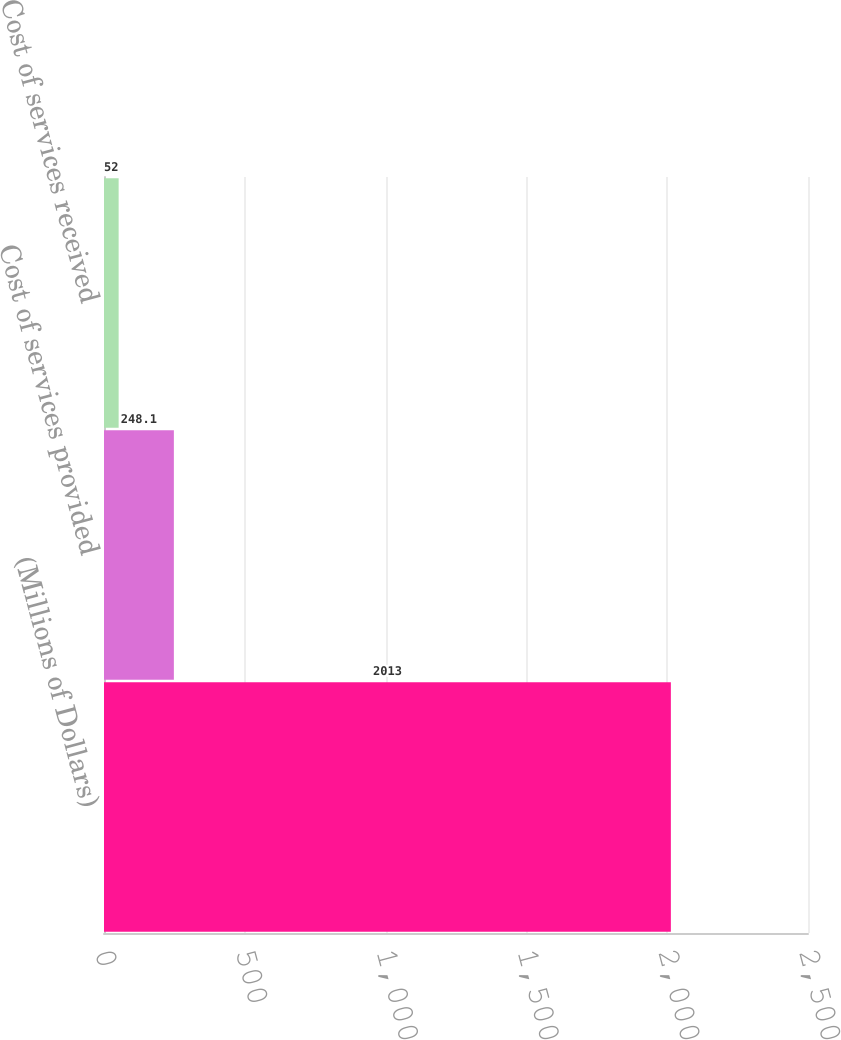Convert chart to OTSL. <chart><loc_0><loc_0><loc_500><loc_500><bar_chart><fcel>(Millions of Dollars)<fcel>Cost of services provided<fcel>Cost of services received<nl><fcel>2013<fcel>248.1<fcel>52<nl></chart> 